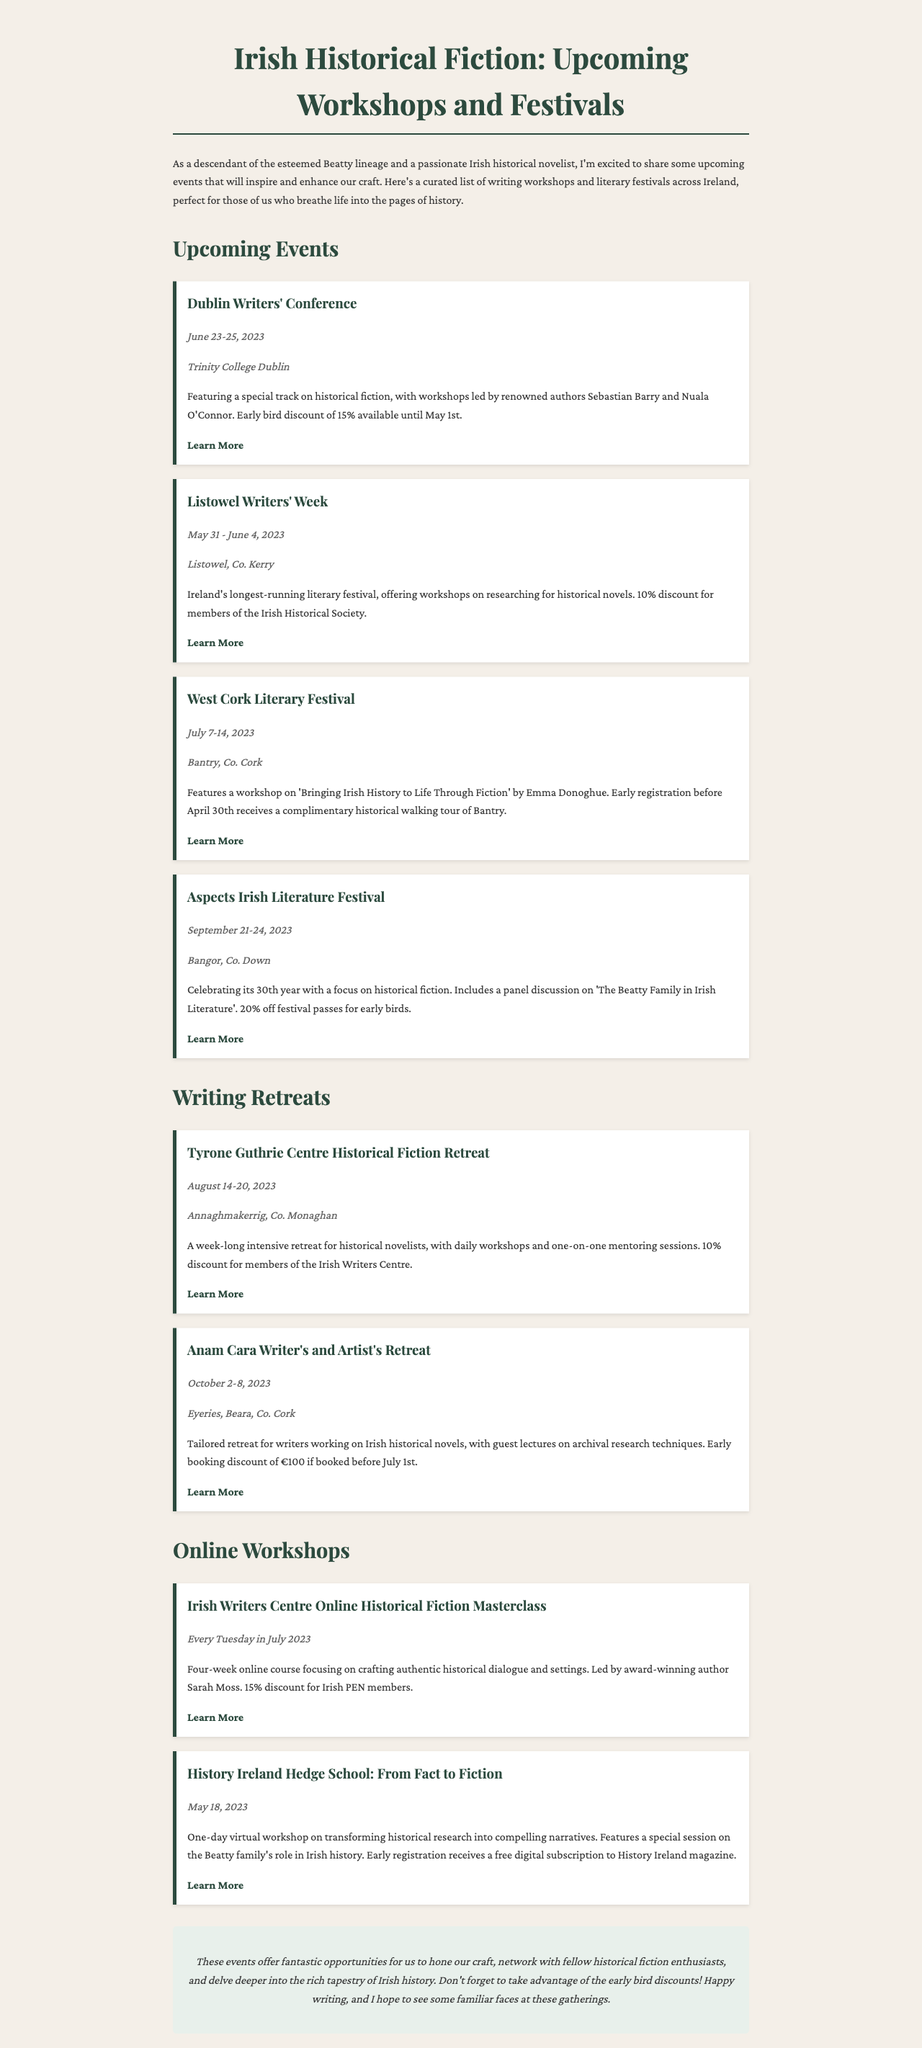What is the date of the Dublin Writers' Conference? The date is listed directly in the document under the event section for the Dublin Writers' Conference.
Answer: June 23-25, 2023 Where is the Listowel Writers' Week being held? The location is specified in the document alongside the event description for Listowel Writers' Week.
Answer: Listowel, Co. Kerry Who is leading the workshop at the West Cork Literary Festival? The workshop leader is mentioned in the description of the event for the West Cork Literary Festival.
Answer: Emma Donoghue What is the early registration discount for the Aspects Irish Literature Festival? The discount percentage is noted in the festival's description in the document.
Answer: 20% Which writing retreat offers guest lectures on archival research techniques? The document specifies this feature in the description of the writing retreat.
Answer: Anam Cara Writer's and Artist's Retreat How many weeks does the Irish Writers Centre Online Historical Fiction Masterclass last? The duration is mentioned in the description section of the online workshops.
Answer: Four weeks What special session is featured in the History Ireland Hedge School? The specific session is highlighted in the workshop's description in the document.
Answer: The Beatty family's role in Irish history What is the discount for members of the Irish Historical Society at the Listowel Writers' Week? This information is provided in the event's description within the document.
Answer: 10% What is emphasized in the introduction of the newsletter? The introduction explains the purpose and excitement regarding the upcoming events for historical novelists.
Answer: Inspiration and enhancement of craft 